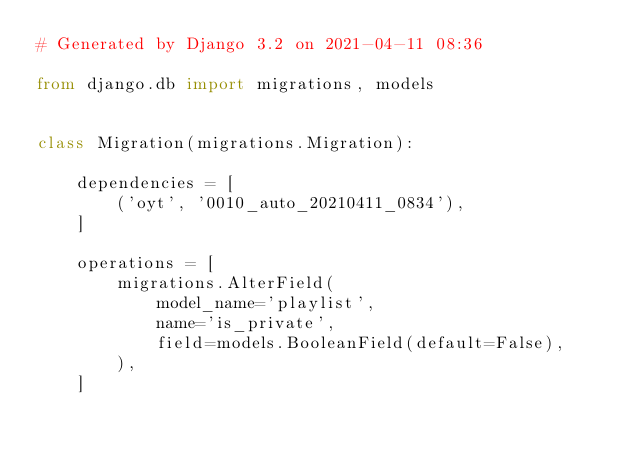Convert code to text. <code><loc_0><loc_0><loc_500><loc_500><_Python_># Generated by Django 3.2 on 2021-04-11 08:36

from django.db import migrations, models


class Migration(migrations.Migration):

    dependencies = [
        ('oyt', '0010_auto_20210411_0834'),
    ]

    operations = [
        migrations.AlterField(
            model_name='playlist',
            name='is_private',
            field=models.BooleanField(default=False),
        ),
    ]
</code> 